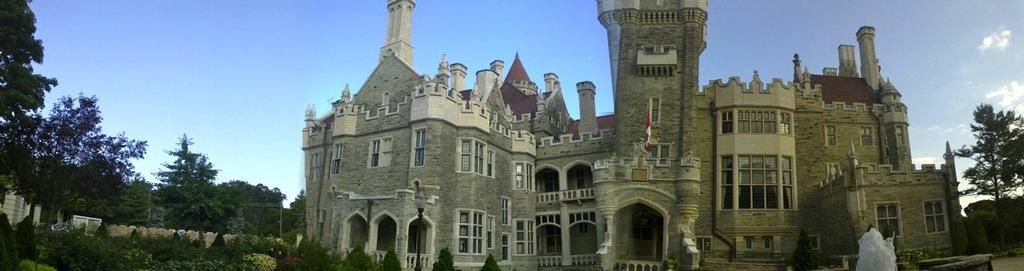What type of structures can be seen in the image? There are buildings in the image. What feature is common to some of the buildings? There are windows in the image. What water feature is present in the image? There is a fountain in the image. What type of vegetation can be seen in the image? There are trees and plants in the image. What part of the natural environment is visible in the image? The sky is visible in the image. Can you tell me how many zippers are visible on the trees in the image? There are no zippers present on the trees in the image; they are natural vegetation. What type of coat is hanging on the fountain in the image? There is no coat present on the fountain in the image. 